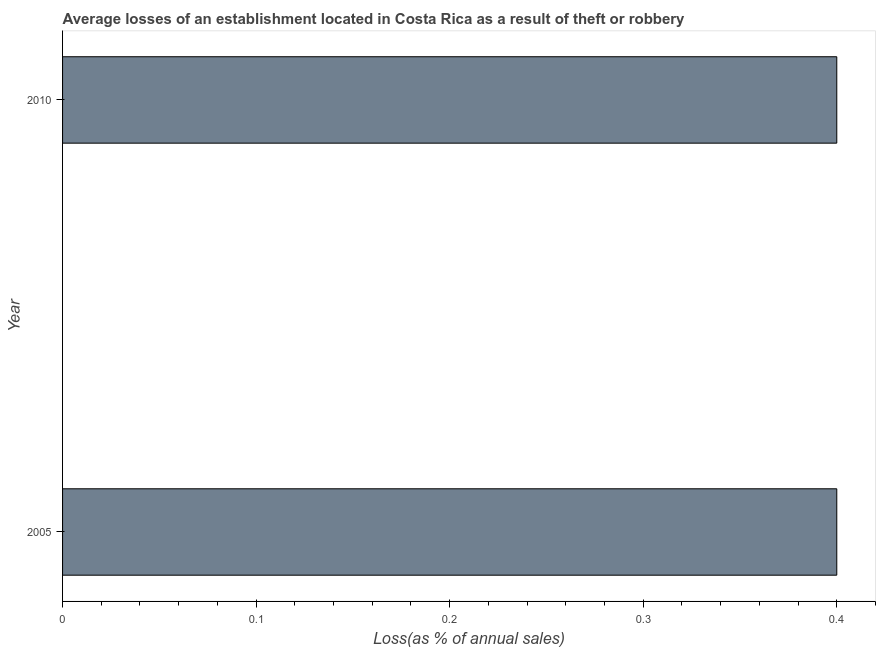Does the graph contain any zero values?
Provide a short and direct response. No. Does the graph contain grids?
Ensure brevity in your answer.  No. What is the title of the graph?
Your response must be concise. Average losses of an establishment located in Costa Rica as a result of theft or robbery. What is the label or title of the X-axis?
Make the answer very short. Loss(as % of annual sales). What is the label or title of the Y-axis?
Keep it short and to the point. Year. In which year was the losses due to theft minimum?
Your answer should be compact. 2005. What is the median losses due to theft?
Your response must be concise. 0.4. Do a majority of the years between 2010 and 2005 (inclusive) have losses due to theft greater than 0.3 %?
Provide a succinct answer. No. How many bars are there?
Your answer should be very brief. 2. Are all the bars in the graph horizontal?
Keep it short and to the point. Yes. What is the difference between two consecutive major ticks on the X-axis?
Offer a very short reply. 0.1. What is the difference between the Loss(as % of annual sales) in 2005 and 2010?
Provide a succinct answer. 0. 